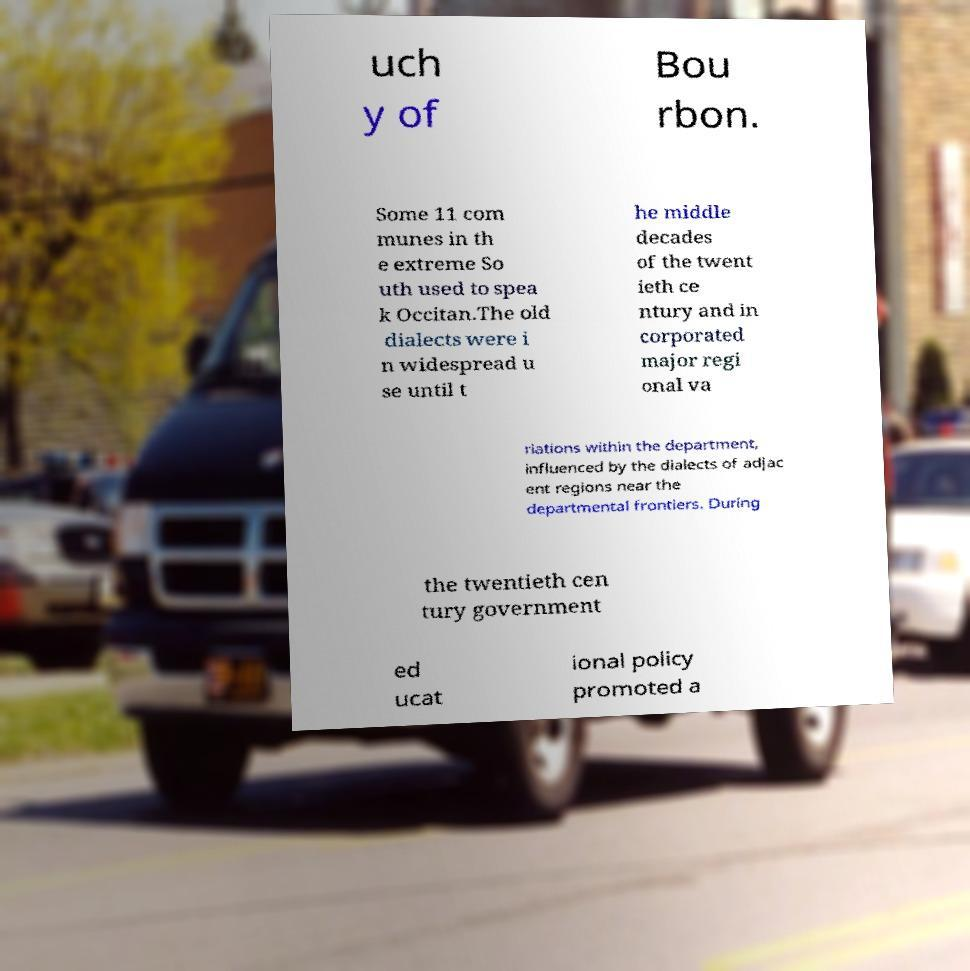Can you read and provide the text displayed in the image?This photo seems to have some interesting text. Can you extract and type it out for me? uch y of Bou rbon. Some 11 com munes in th e extreme So uth used to spea k Occitan.The old dialects were i n widespread u se until t he middle decades of the twent ieth ce ntury and in corporated major regi onal va riations within the department, influenced by the dialects of adjac ent regions near the departmental frontiers. During the twentieth cen tury government ed ucat ional policy promoted a 